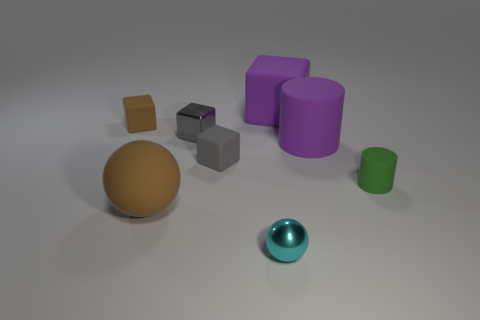What shape is the rubber thing that is the same color as the large matte ball?
Keep it short and to the point. Cube. What number of purple matte blocks are the same size as the cyan metallic sphere?
Your response must be concise. 0. Are the big thing that is to the left of the tiny cyan object and the purple cube made of the same material?
Your answer should be compact. Yes. Are there any tiny yellow matte objects?
Provide a short and direct response. No. There is a gray block that is the same material as the small green object; what size is it?
Your answer should be very brief. Small. Are there any objects that have the same color as the matte sphere?
Offer a terse response. Yes. Is the color of the small rubber cube that is on the right side of the small brown object the same as the small metallic thing that is behind the big brown thing?
Provide a succinct answer. Yes. There is a block that is the same color as the big rubber cylinder; what is its size?
Provide a succinct answer. Large. Is there a cyan cylinder made of the same material as the purple cylinder?
Your answer should be very brief. No. The shiny cube is what color?
Offer a terse response. Gray. 